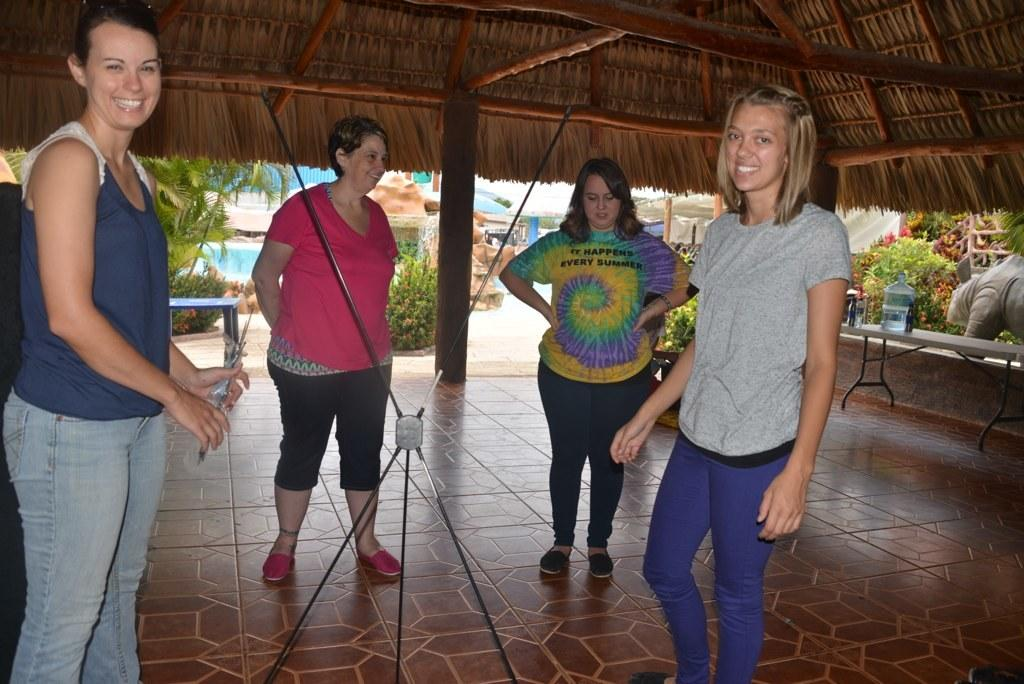How many women are in the image? There are four women in the image. Where are the women standing in the image? The women are standing under a shed. What is the facial expression of the women in the image? The women are smiling. What can be seen outside the shed in the image? There are plants visible outside the shed. What else can be seen in the image besides the women and the shed? There are other houses visible in the image. What type of leather is being used to construct the shed in the image? There is no mention of leather in the image, and the shed's construction material is not specified. What is the answer to the question the women are discussing in the image? There is no indication of a discussion or a question being asked in the image, so it is impossible to determine the answer. 